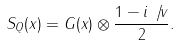Convert formula to latex. <formula><loc_0><loc_0><loc_500><loc_500>S _ { Q } ( x ) = G ( x ) \otimes \frac { 1 - i \not { \, v } } { 2 } .</formula> 